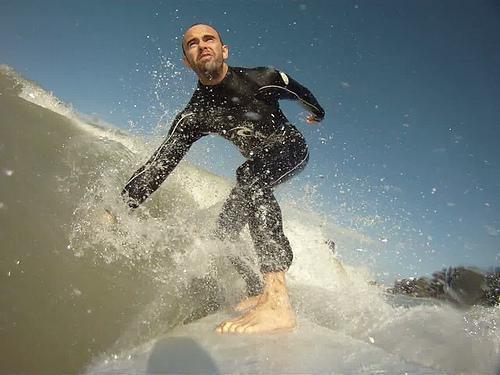How many sinks do you see?
Give a very brief answer. 0. 